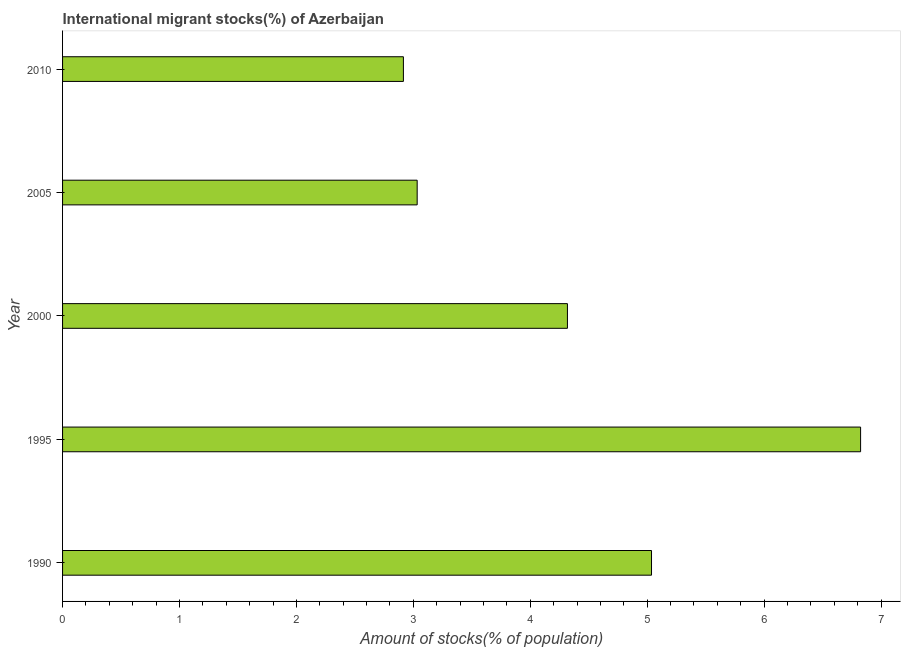Does the graph contain grids?
Your answer should be compact. No. What is the title of the graph?
Give a very brief answer. International migrant stocks(%) of Azerbaijan. What is the label or title of the X-axis?
Your answer should be very brief. Amount of stocks(% of population). What is the number of international migrant stocks in 1995?
Give a very brief answer. 6.83. Across all years, what is the maximum number of international migrant stocks?
Provide a succinct answer. 6.83. Across all years, what is the minimum number of international migrant stocks?
Your answer should be very brief. 2.92. In which year was the number of international migrant stocks minimum?
Give a very brief answer. 2010. What is the sum of the number of international migrant stocks?
Provide a succinct answer. 22.13. What is the difference between the number of international migrant stocks in 2000 and 2010?
Ensure brevity in your answer.  1.4. What is the average number of international migrant stocks per year?
Your answer should be very brief. 4.43. What is the median number of international migrant stocks?
Offer a very short reply. 4.32. What is the ratio of the number of international migrant stocks in 1995 to that in 2000?
Provide a succinct answer. 1.58. Is the number of international migrant stocks in 2000 less than that in 2010?
Keep it short and to the point. No. Is the difference between the number of international migrant stocks in 1995 and 2005 greater than the difference between any two years?
Your answer should be very brief. No. What is the difference between the highest and the second highest number of international migrant stocks?
Provide a short and direct response. 1.79. What is the difference between the highest and the lowest number of international migrant stocks?
Your answer should be compact. 3.91. In how many years, is the number of international migrant stocks greater than the average number of international migrant stocks taken over all years?
Offer a very short reply. 2. How many bars are there?
Your answer should be very brief. 5. Are all the bars in the graph horizontal?
Keep it short and to the point. Yes. What is the difference between two consecutive major ticks on the X-axis?
Keep it short and to the point. 1. What is the Amount of stocks(% of population) in 1990?
Provide a short and direct response. 5.04. What is the Amount of stocks(% of population) in 1995?
Provide a short and direct response. 6.83. What is the Amount of stocks(% of population) in 2000?
Make the answer very short. 4.32. What is the Amount of stocks(% of population) of 2005?
Your answer should be very brief. 3.03. What is the Amount of stocks(% of population) in 2010?
Offer a very short reply. 2.92. What is the difference between the Amount of stocks(% of population) in 1990 and 1995?
Ensure brevity in your answer.  -1.79. What is the difference between the Amount of stocks(% of population) in 1990 and 2000?
Offer a terse response. 0.72. What is the difference between the Amount of stocks(% of population) in 1990 and 2005?
Your response must be concise. 2. What is the difference between the Amount of stocks(% of population) in 1990 and 2010?
Ensure brevity in your answer.  2.12. What is the difference between the Amount of stocks(% of population) in 1995 and 2000?
Provide a succinct answer. 2.51. What is the difference between the Amount of stocks(% of population) in 1995 and 2005?
Make the answer very short. 3.79. What is the difference between the Amount of stocks(% of population) in 1995 and 2010?
Provide a succinct answer. 3.91. What is the difference between the Amount of stocks(% of population) in 2000 and 2005?
Keep it short and to the point. 1.29. What is the difference between the Amount of stocks(% of population) in 2000 and 2010?
Keep it short and to the point. 1.4. What is the difference between the Amount of stocks(% of population) in 2005 and 2010?
Ensure brevity in your answer.  0.12. What is the ratio of the Amount of stocks(% of population) in 1990 to that in 1995?
Your response must be concise. 0.74. What is the ratio of the Amount of stocks(% of population) in 1990 to that in 2000?
Ensure brevity in your answer.  1.17. What is the ratio of the Amount of stocks(% of population) in 1990 to that in 2005?
Give a very brief answer. 1.66. What is the ratio of the Amount of stocks(% of population) in 1990 to that in 2010?
Offer a terse response. 1.73. What is the ratio of the Amount of stocks(% of population) in 1995 to that in 2000?
Ensure brevity in your answer.  1.58. What is the ratio of the Amount of stocks(% of population) in 1995 to that in 2005?
Keep it short and to the point. 2.25. What is the ratio of the Amount of stocks(% of population) in 1995 to that in 2010?
Provide a succinct answer. 2.34. What is the ratio of the Amount of stocks(% of population) in 2000 to that in 2005?
Your answer should be very brief. 1.42. What is the ratio of the Amount of stocks(% of population) in 2000 to that in 2010?
Your answer should be compact. 1.48. What is the ratio of the Amount of stocks(% of population) in 2005 to that in 2010?
Provide a succinct answer. 1.04. 